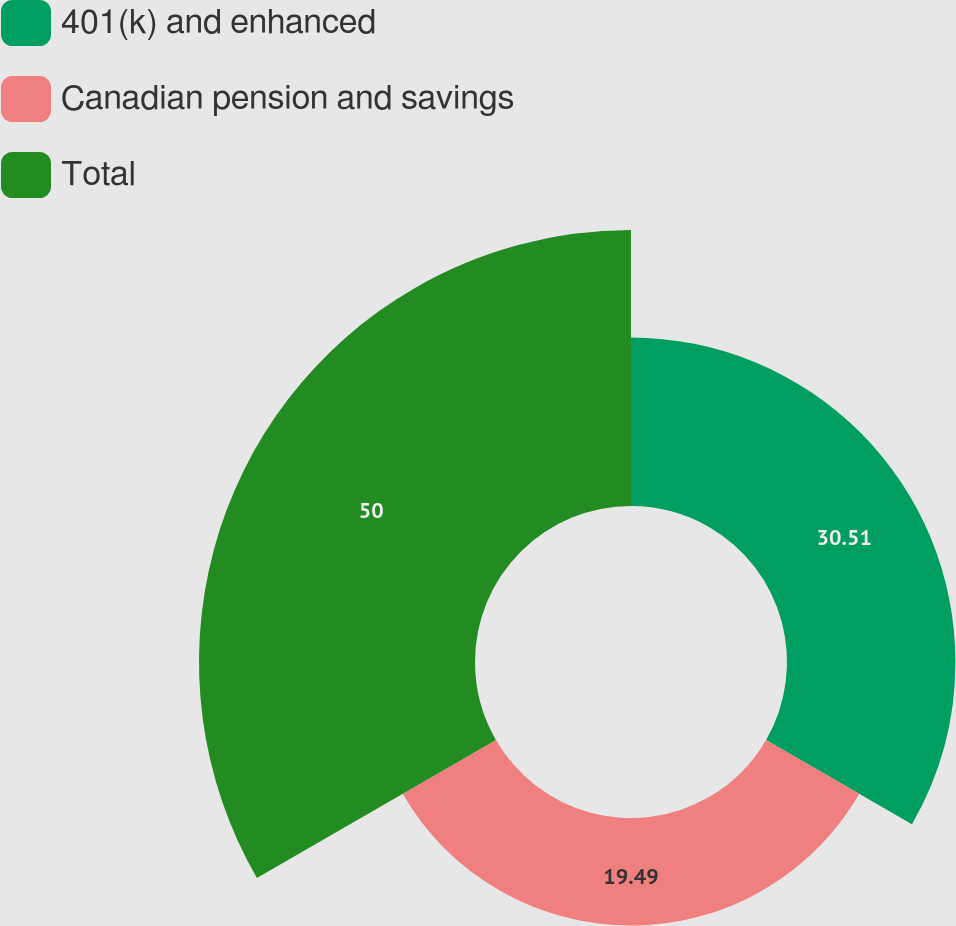Convert chart. <chart><loc_0><loc_0><loc_500><loc_500><pie_chart><fcel>401(k) and enhanced<fcel>Canadian pension and savings<fcel>Total<nl><fcel>30.51%<fcel>19.49%<fcel>50.0%<nl></chart> 